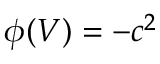<formula> <loc_0><loc_0><loc_500><loc_500>\phi ( V ) = - c ^ { 2 }</formula> 